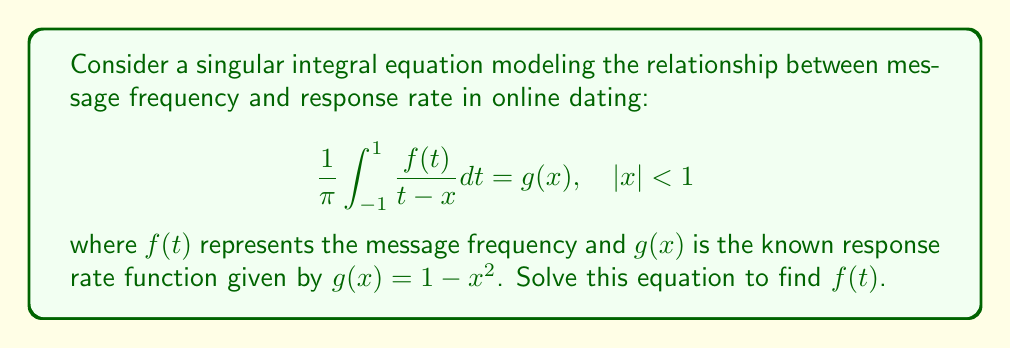Help me with this question. To solve this singular integral equation, we'll follow these steps:

1) Recognize this as a Cauchy singular integral equation of the first kind.

2) The general solution for this type of equation is given by the Poincaré-Bertrand formula:

   $$f(t) = \frac{C}{\sqrt{1-t^2}} + \frac{\sqrt{1-t^2}}{\pi} \int_{-1}^{1} \frac{g(x)}{(x-t)\sqrt{1-x^2}} dx$$

   where $C$ is a constant.

3) Substitute $g(x) = 1 - x^2$ into the integral:

   $$f(t) = \frac{C}{\sqrt{1-t^2}} + \frac{\sqrt{1-t^2}}{\pi} \int_{-1}^{1} \frac{1-x^2}{(x-t)\sqrt{1-x^2}} dx$$

4) Simplify the integral:

   $$f(t) = \frac{C}{\sqrt{1-t^2}} + \frac{\sqrt{1-t^2}}{\pi} \int_{-1}^{1} \frac{\sqrt{1-x^2}}{x-t} dx - \frac{\sqrt{1-t^2}}{\pi} \int_{-1}^{1} \frac{x}{\sqrt{1-x^2}} \frac{dx}{x-t}$$

5) The first integral evaluates to $-\pi$ for $|t| < 1$. The second integral is zero due to odd symmetry.

6) Therefore, our solution becomes:

   $$f(t) = \frac{C}{\sqrt{1-t^2}} - \sqrt{1-t^2}$$

7) To determine $C$, we can use the condition that the integral of $f(t)$ over $[-1,1]$ should be finite. This requires $C = 0$.

8) Thus, our final solution is:

   $$f(t) = -\sqrt{1-t^2}$$

This function represents the optimal message frequency to maximize response rate in the given model.
Answer: $f(t) = -\sqrt{1-t^2}$ 